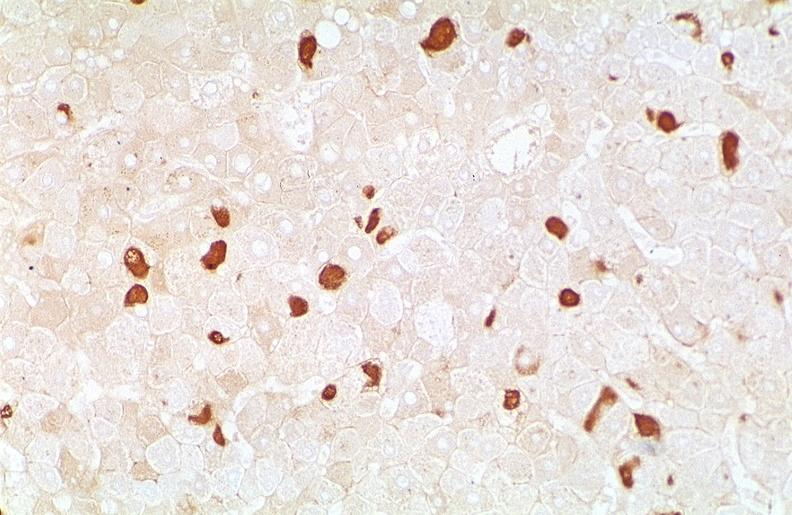s hepatobiliary present?
Answer the question using a single word or phrase. Yes 